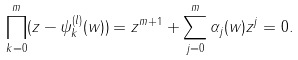<formula> <loc_0><loc_0><loc_500><loc_500>\prod _ { k = 0 } ^ { m } ( z - \psi ^ { ( l ) } _ { k } ( w ) ) = z ^ { m + 1 } + \sum _ { j = 0 } ^ { m } \alpha _ { j } ( w ) z ^ { j } = 0 .</formula> 